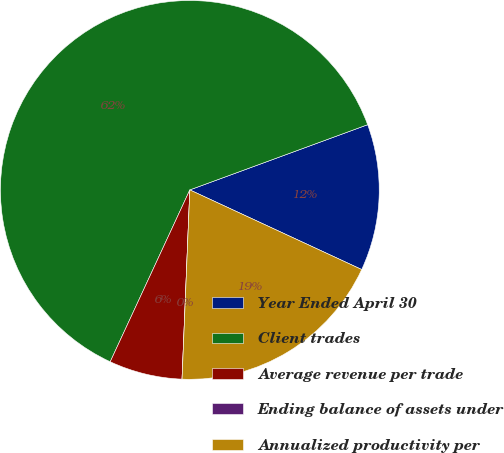Convert chart. <chart><loc_0><loc_0><loc_500><loc_500><pie_chart><fcel>Year Ended April 30<fcel>Client trades<fcel>Average revenue per trade<fcel>Ending balance of assets under<fcel>Annualized productivity per<nl><fcel>12.5%<fcel>62.5%<fcel>6.25%<fcel>0.0%<fcel>18.75%<nl></chart> 